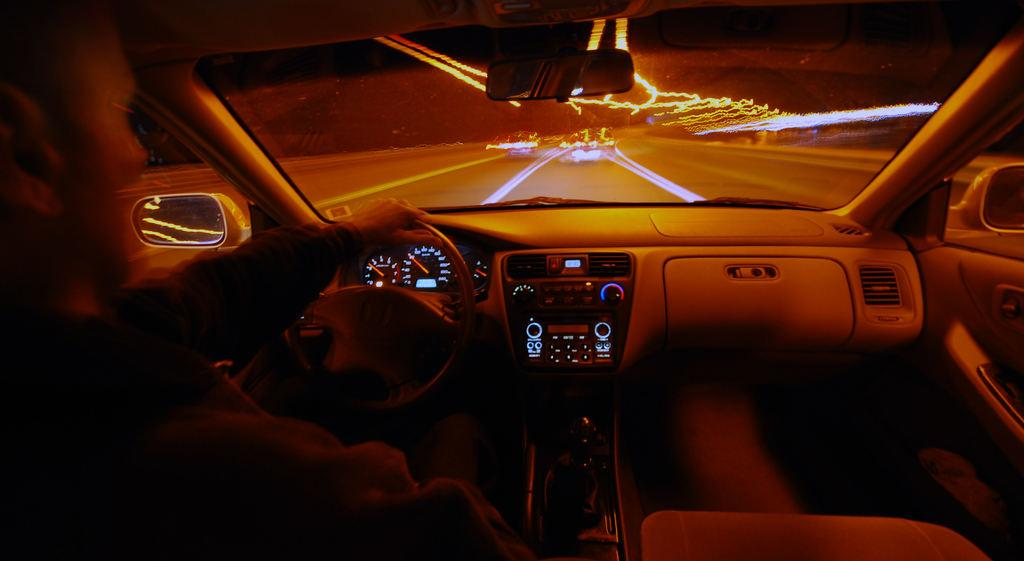What is the setting of the image? The image is taken inside a vehicle. Who is operating the vehicle? There is a person holding the steering. What can be seen outside the vehicle in the image? There are other vehicles visible on the road. What instrument is present behind the steering? There is a meter indicator behind the steering. What type of birds can be seen writing on the meter indicator in the image? There are no birds or writing present on the meter indicator in the image. 